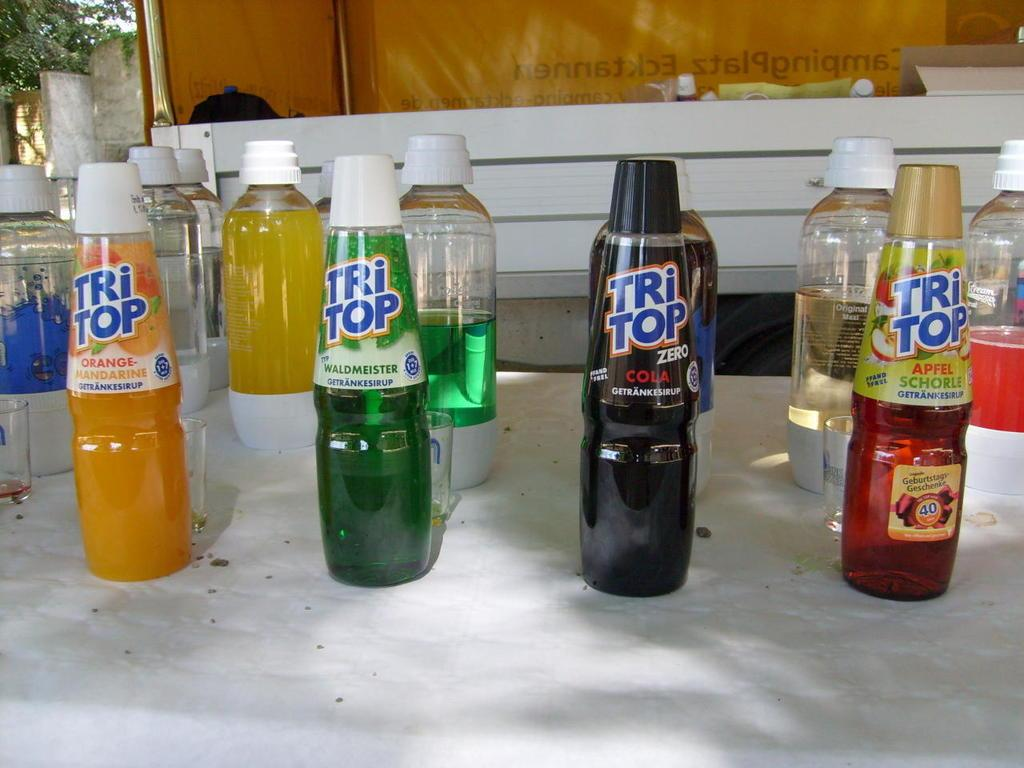<image>
Summarize the visual content of the image. A series of Tri Top beverages next to each other on a table. 